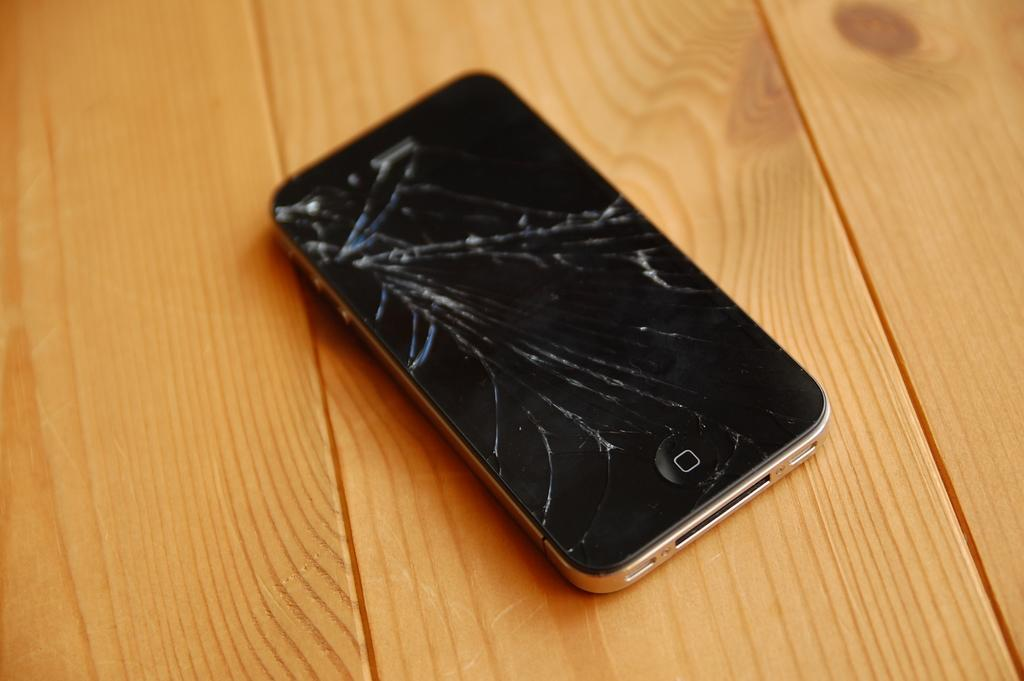Provide a one-sentence caption for the provided image. A smart phone, in which you can only see the home button on the bottom, has a screen that is almost completely shattered. 